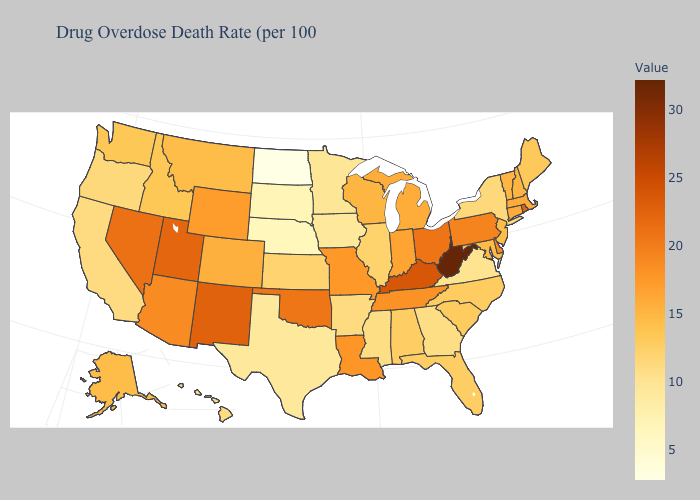Among the states that border West Virginia , which have the highest value?
Answer briefly. Kentucky. Among the states that border Nevada , does Utah have the lowest value?
Concise answer only. No. Does Louisiana have a higher value than South Dakota?
Concise answer only. Yes. Is the legend a continuous bar?
Concise answer only. Yes. Is the legend a continuous bar?
Write a very short answer. Yes. Does Montana have the lowest value in the West?
Short answer required. No. Among the states that border Oklahoma , does Arkansas have the highest value?
Answer briefly. No. 